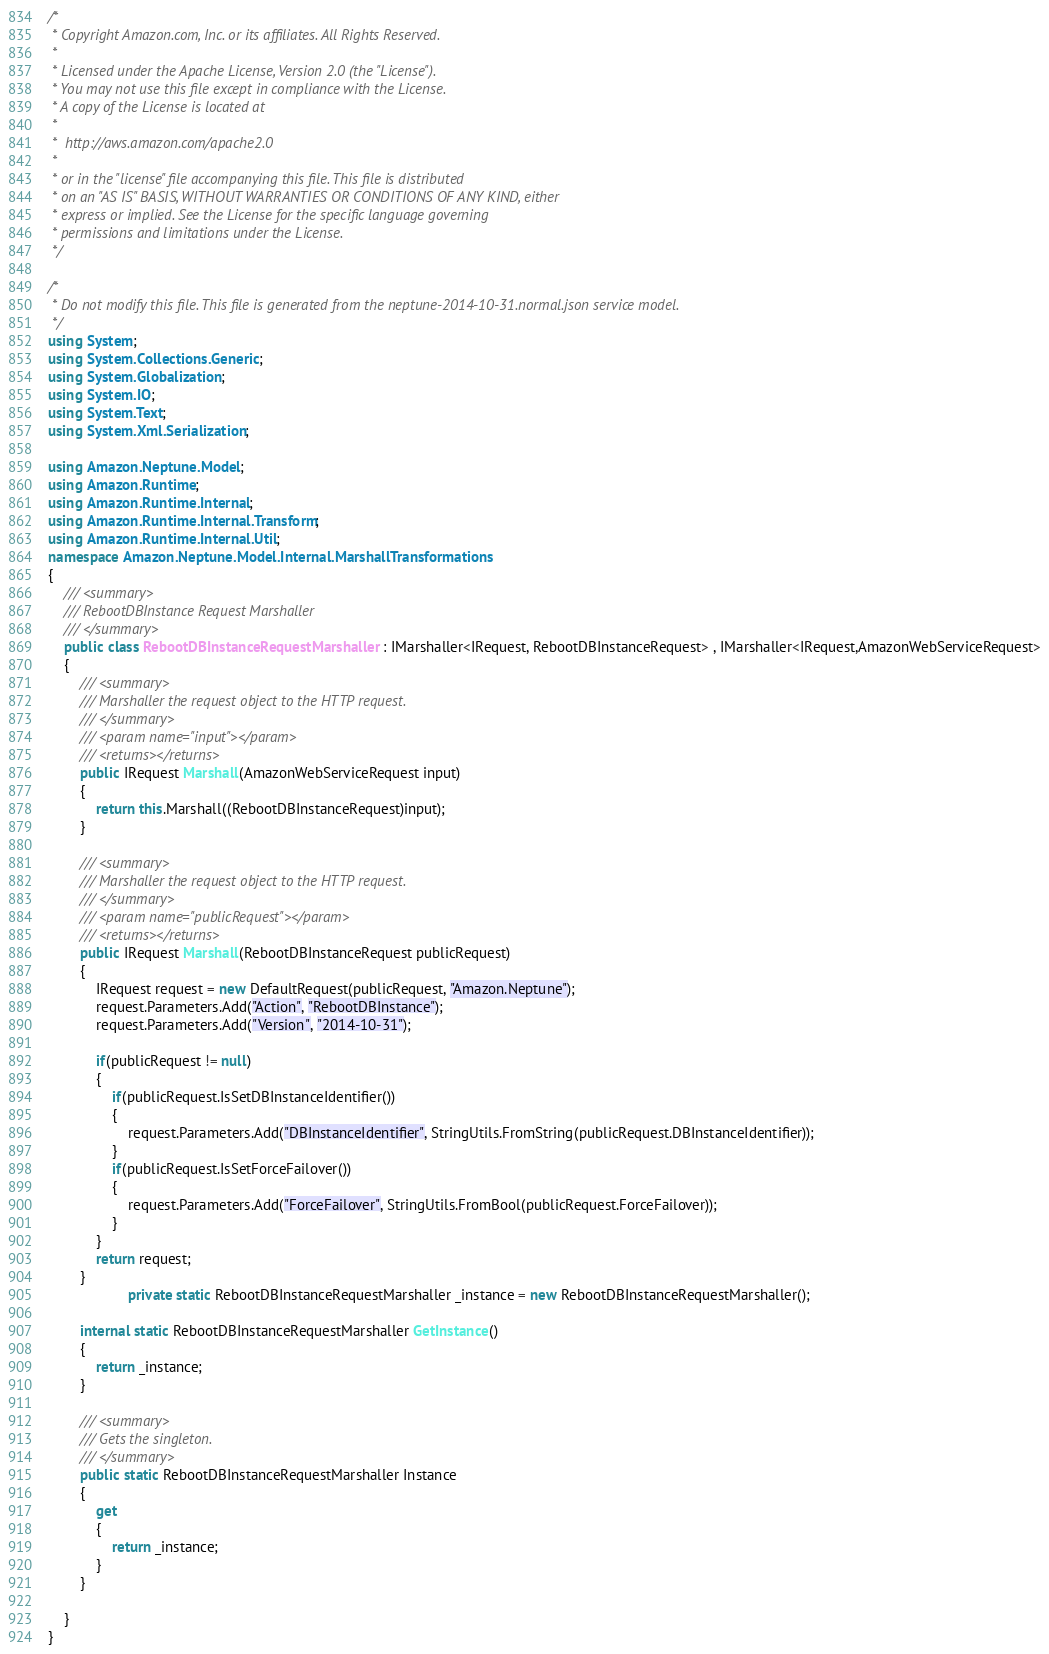<code> <loc_0><loc_0><loc_500><loc_500><_C#_>/*
 * Copyright Amazon.com, Inc. or its affiliates. All Rights Reserved.
 * 
 * Licensed under the Apache License, Version 2.0 (the "License").
 * You may not use this file except in compliance with the License.
 * A copy of the License is located at
 * 
 *  http://aws.amazon.com/apache2.0
 * 
 * or in the "license" file accompanying this file. This file is distributed
 * on an "AS IS" BASIS, WITHOUT WARRANTIES OR CONDITIONS OF ANY KIND, either
 * express or implied. See the License for the specific language governing
 * permissions and limitations under the License.
 */

/*
 * Do not modify this file. This file is generated from the neptune-2014-10-31.normal.json service model.
 */
using System;
using System.Collections.Generic;
using System.Globalization;
using System.IO;
using System.Text;
using System.Xml.Serialization;

using Amazon.Neptune.Model;
using Amazon.Runtime;
using Amazon.Runtime.Internal;
using Amazon.Runtime.Internal.Transform;
using Amazon.Runtime.Internal.Util;
namespace Amazon.Neptune.Model.Internal.MarshallTransformations
{
    /// <summary>
    /// RebootDBInstance Request Marshaller
    /// </summary>       
    public class RebootDBInstanceRequestMarshaller : IMarshaller<IRequest, RebootDBInstanceRequest> , IMarshaller<IRequest,AmazonWebServiceRequest>
    {
        /// <summary>
        /// Marshaller the request object to the HTTP request.
        /// </summary>  
        /// <param name="input"></param>
        /// <returns></returns>
        public IRequest Marshall(AmazonWebServiceRequest input)
        {
            return this.Marshall((RebootDBInstanceRequest)input);
        }
    
        /// <summary>
        /// Marshaller the request object to the HTTP request.
        /// </summary>  
        /// <param name="publicRequest"></param>
        /// <returns></returns>
        public IRequest Marshall(RebootDBInstanceRequest publicRequest)
        {
            IRequest request = new DefaultRequest(publicRequest, "Amazon.Neptune");
            request.Parameters.Add("Action", "RebootDBInstance");
            request.Parameters.Add("Version", "2014-10-31");

            if(publicRequest != null)
            {
                if(publicRequest.IsSetDBInstanceIdentifier())
                {
                    request.Parameters.Add("DBInstanceIdentifier", StringUtils.FromString(publicRequest.DBInstanceIdentifier));
                }
                if(publicRequest.IsSetForceFailover())
                {
                    request.Parameters.Add("ForceFailover", StringUtils.FromBool(publicRequest.ForceFailover));
                }
            }
            return request;
        }
                    private static RebootDBInstanceRequestMarshaller _instance = new RebootDBInstanceRequestMarshaller();        

        internal static RebootDBInstanceRequestMarshaller GetInstance()
        {
            return _instance;
        }

        /// <summary>
        /// Gets the singleton.
        /// </summary>  
        public static RebootDBInstanceRequestMarshaller Instance
        {
            get
            {
                return _instance;
            }
        }

    }
}</code> 